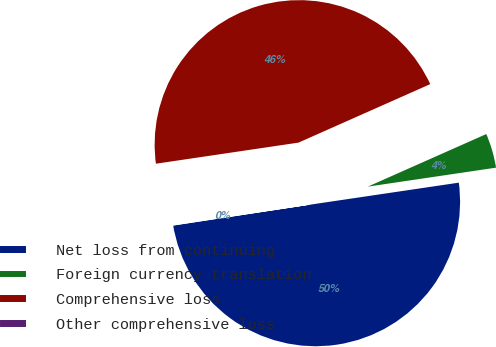<chart> <loc_0><loc_0><loc_500><loc_500><pie_chart><fcel>Net loss from continuing<fcel>Foreign currency translation<fcel>Comprehensive loss<fcel>Other comprehensive loss<nl><fcel>49.93%<fcel>4.31%<fcel>45.69%<fcel>0.07%<nl></chart> 